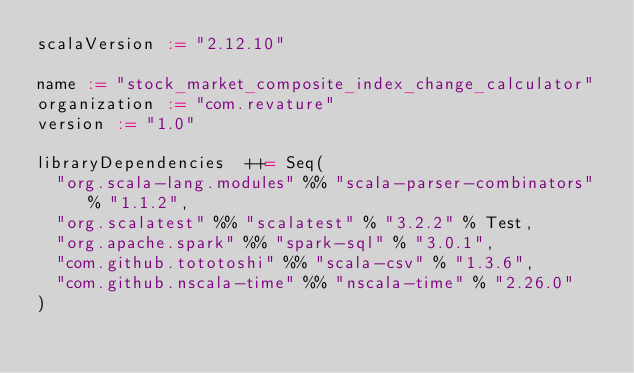<code> <loc_0><loc_0><loc_500><loc_500><_Scala_>scalaVersion := "2.12.10"

name := "stock_market_composite_index_change_calculator"
organization := "com.revature"
version := "1.0"

libraryDependencies  ++= Seq(
  "org.scala-lang.modules" %% "scala-parser-combinators" % "1.1.2",
  "org.scalatest" %% "scalatest" % "3.2.2" % Test,
  "org.apache.spark" %% "spark-sql" % "3.0.1",
  "com.github.tototoshi" %% "scala-csv" % "1.3.6",
  "com.github.nscala-time" %% "nscala-time" % "2.26.0"
)</code> 